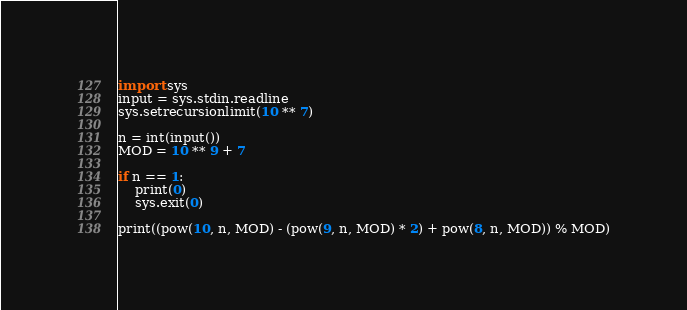<code> <loc_0><loc_0><loc_500><loc_500><_Python_>import sys
input = sys.stdin.readline
sys.setrecursionlimit(10 ** 7)

n = int(input())
MOD = 10 ** 9 + 7

if n == 1:
    print(0)
    sys.exit(0)

print((pow(10, n, MOD) - (pow(9, n, MOD) * 2) + pow(8, n, MOD)) % MOD)
</code> 